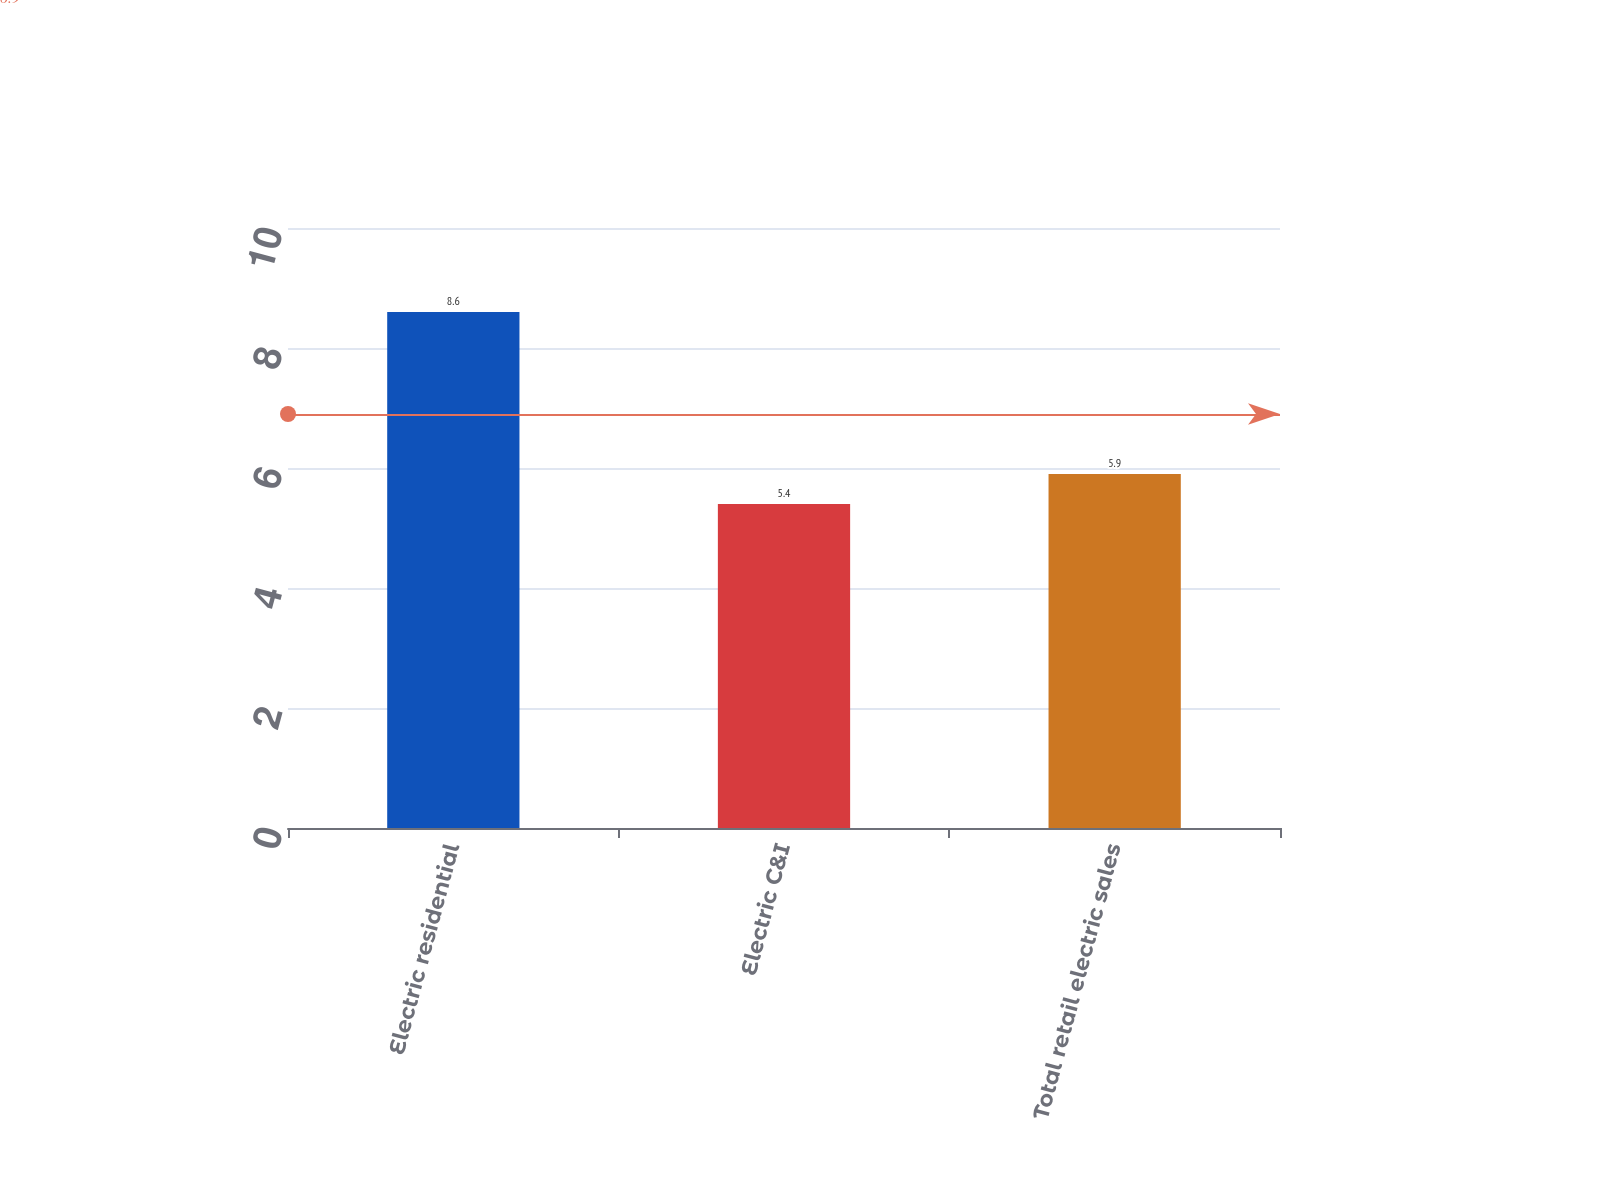<chart> <loc_0><loc_0><loc_500><loc_500><bar_chart><fcel>Electric residential<fcel>Electric C&I<fcel>Total retail electric sales<nl><fcel>8.6<fcel>5.4<fcel>5.9<nl></chart> 